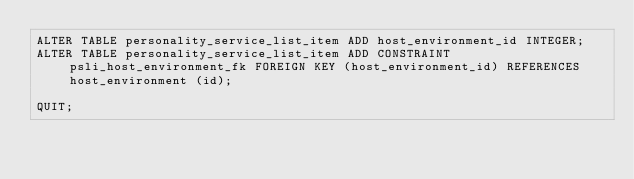<code> <loc_0><loc_0><loc_500><loc_500><_SQL_>ALTER TABLE personality_service_list_item ADD host_environment_id INTEGER;
ALTER TABLE personality_service_list_item ADD CONSTRAINT psli_host_environment_fk FOREIGN KEY (host_environment_id) REFERENCES host_environment (id);

QUIT;
</code> 